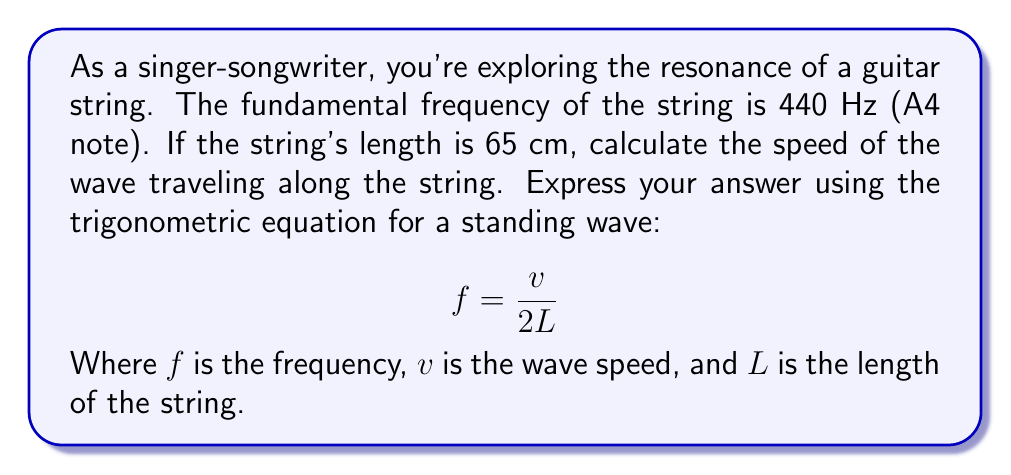Help me with this question. Let's approach this step-by-step:

1) We are given the following information:
   $f = 440$ Hz (frequency)
   $L = 65$ cm = $0.65$ m (length of the string)

2) We need to find $v$ (wave speed) using the equation:

   $$ f = \frac{v}{2L} $$

3) Let's rearrange the equation to solve for $v$:

   $$ v = 2Lf $$

4) Now, let's substitute the known values:

   $$ v = 2 \cdot 0.65 \text{ m} \cdot 440 \text{ Hz} $$

5) Calculate:

   $$ v = 1.3 \text{ m} \cdot 440 \text{ Hz} = 572 \text{ m/s} $$

Therefore, the speed of the wave traveling along the guitar string is 572 m/s.
Answer: 572 m/s 